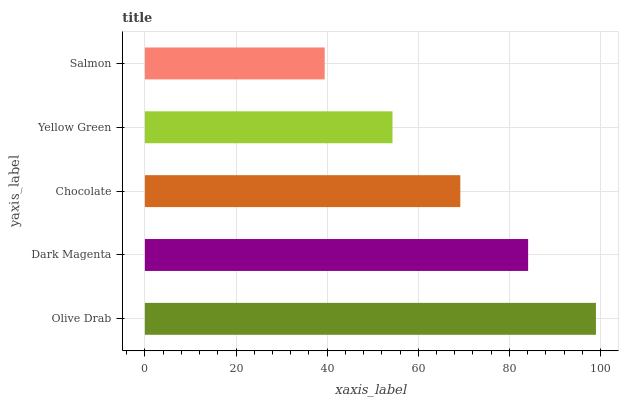Is Salmon the minimum?
Answer yes or no. Yes. Is Olive Drab the maximum?
Answer yes or no. Yes. Is Dark Magenta the minimum?
Answer yes or no. No. Is Dark Magenta the maximum?
Answer yes or no. No. Is Olive Drab greater than Dark Magenta?
Answer yes or no. Yes. Is Dark Magenta less than Olive Drab?
Answer yes or no. Yes. Is Dark Magenta greater than Olive Drab?
Answer yes or no. No. Is Olive Drab less than Dark Magenta?
Answer yes or no. No. Is Chocolate the high median?
Answer yes or no. Yes. Is Chocolate the low median?
Answer yes or no. Yes. Is Dark Magenta the high median?
Answer yes or no. No. Is Olive Drab the low median?
Answer yes or no. No. 